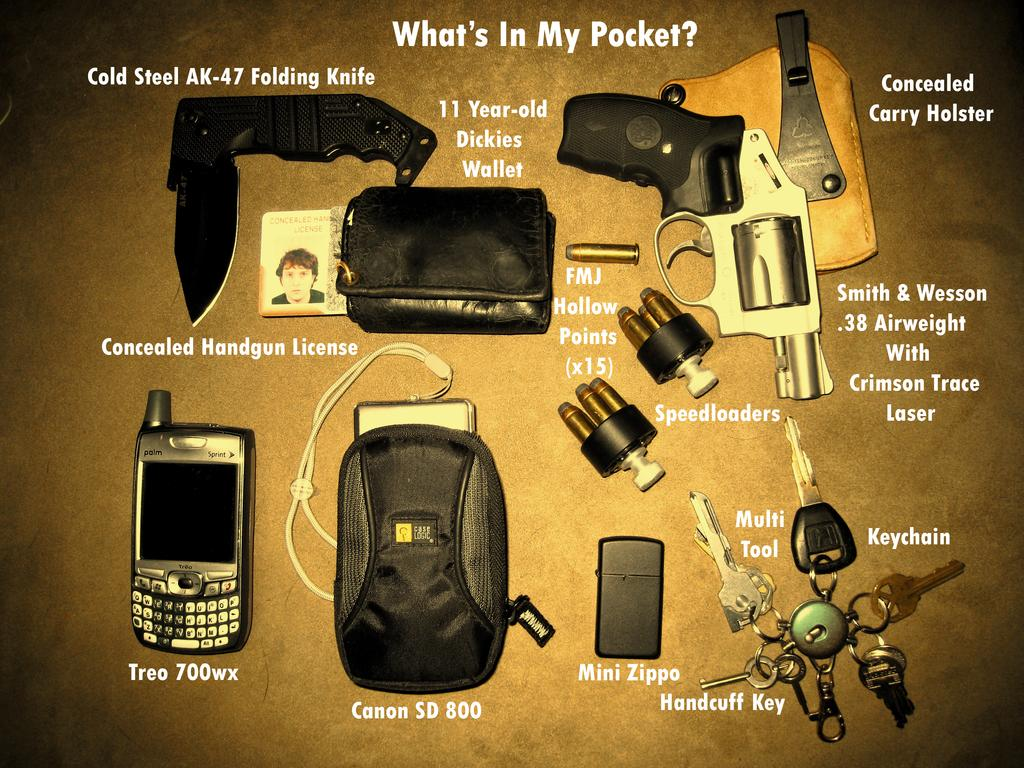<image>
Present a compact description of the photo's key features. a Canon SD 800 is labelled under the bag 